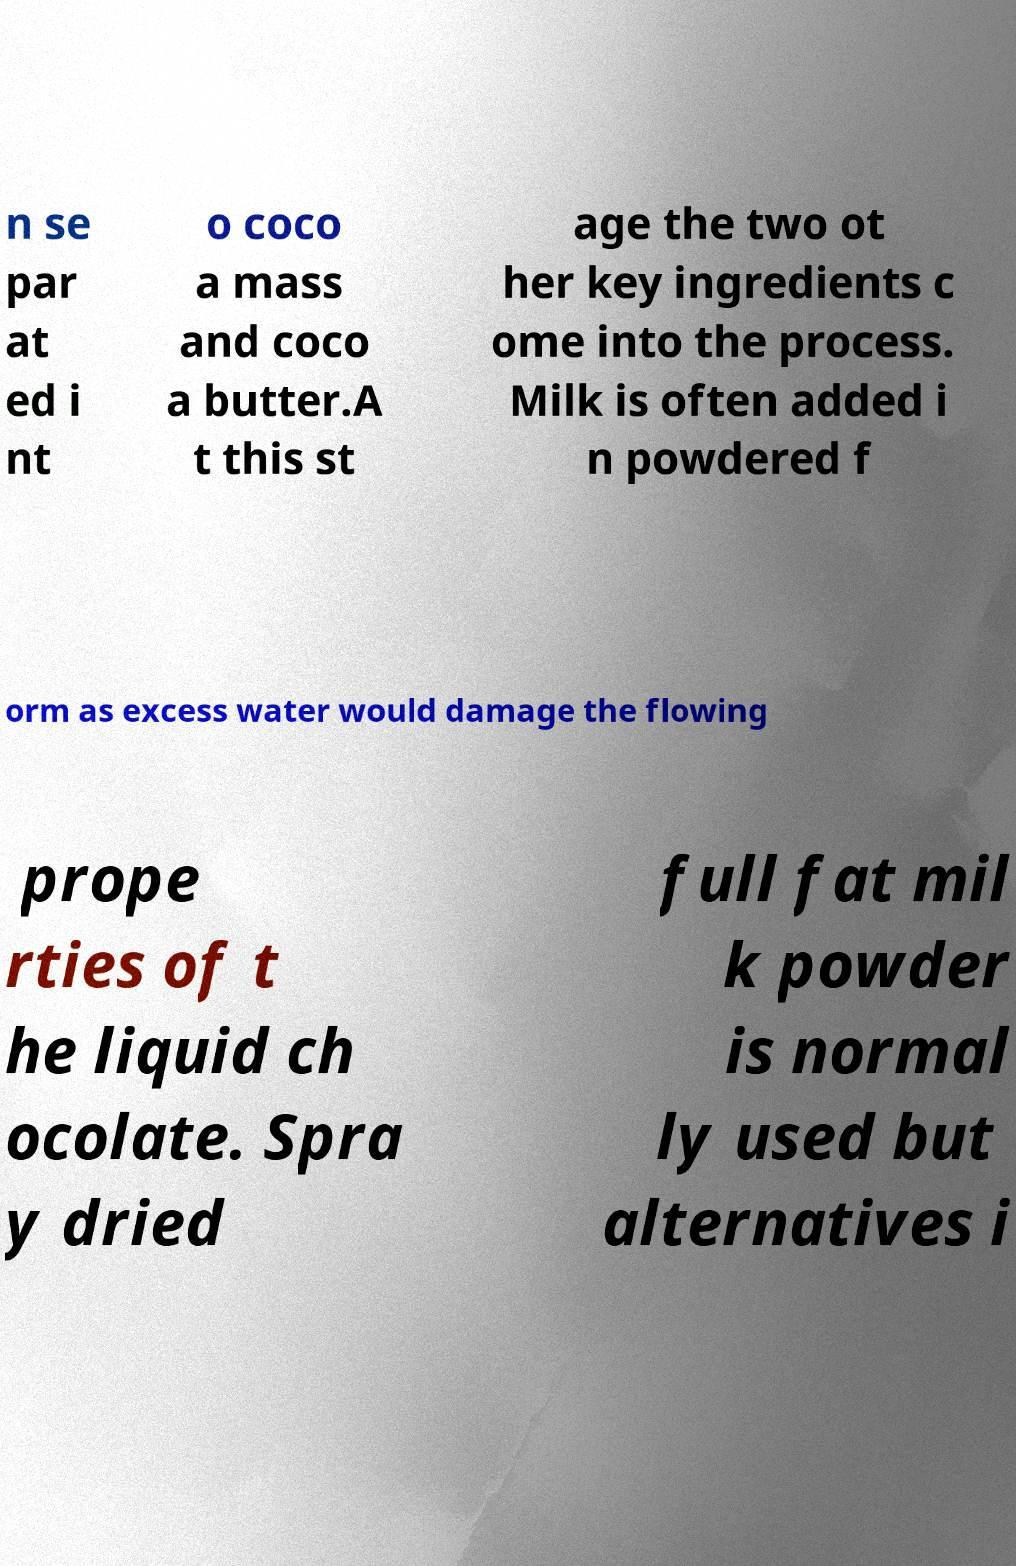For documentation purposes, I need the text within this image transcribed. Could you provide that? n se par at ed i nt o coco a mass and coco a butter.A t this st age the two ot her key ingredients c ome into the process. Milk is often added i n powdered f orm as excess water would damage the flowing prope rties of t he liquid ch ocolate. Spra y dried full fat mil k powder is normal ly used but alternatives i 